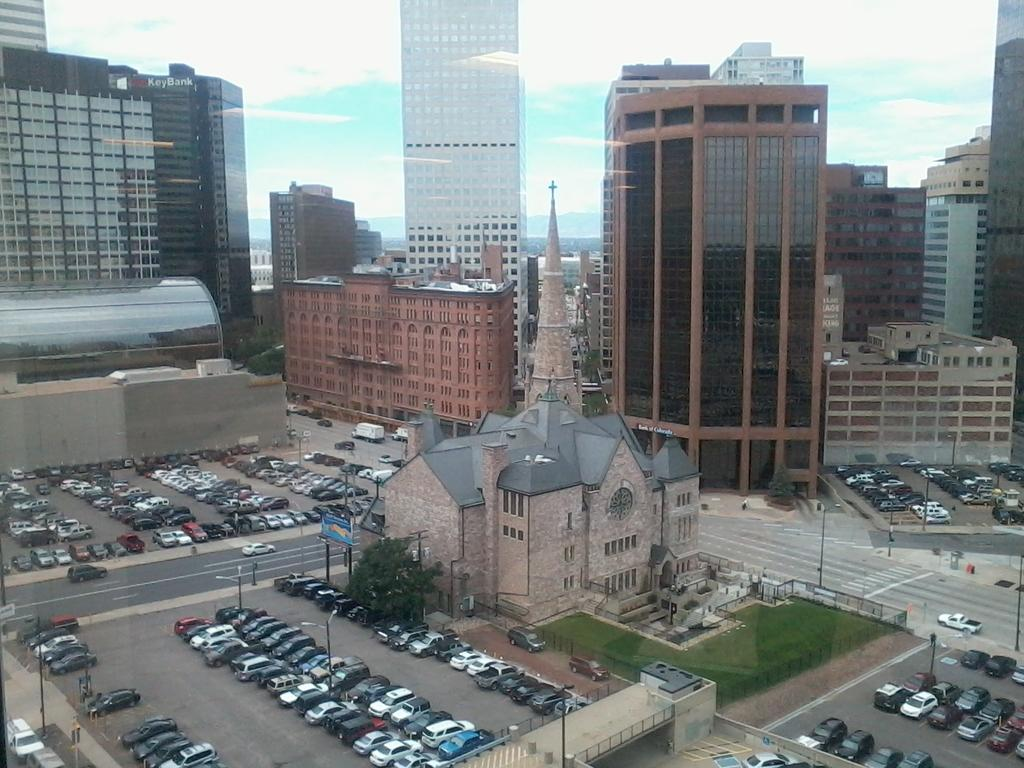What types of objects can be seen in the image? There are vehicles, buildings, and trees in the image. Can you describe the vehicles in the image? The provided facts do not specify the types of vehicles in the image. What kind of structures are depicted in the image? The image contains buildings. What natural elements are present in the image? Trees are present in the image. What type of bread can be seen floating in the ocean in the image? There is no bread or ocean present in the image; it features vehicles, buildings, and trees. 